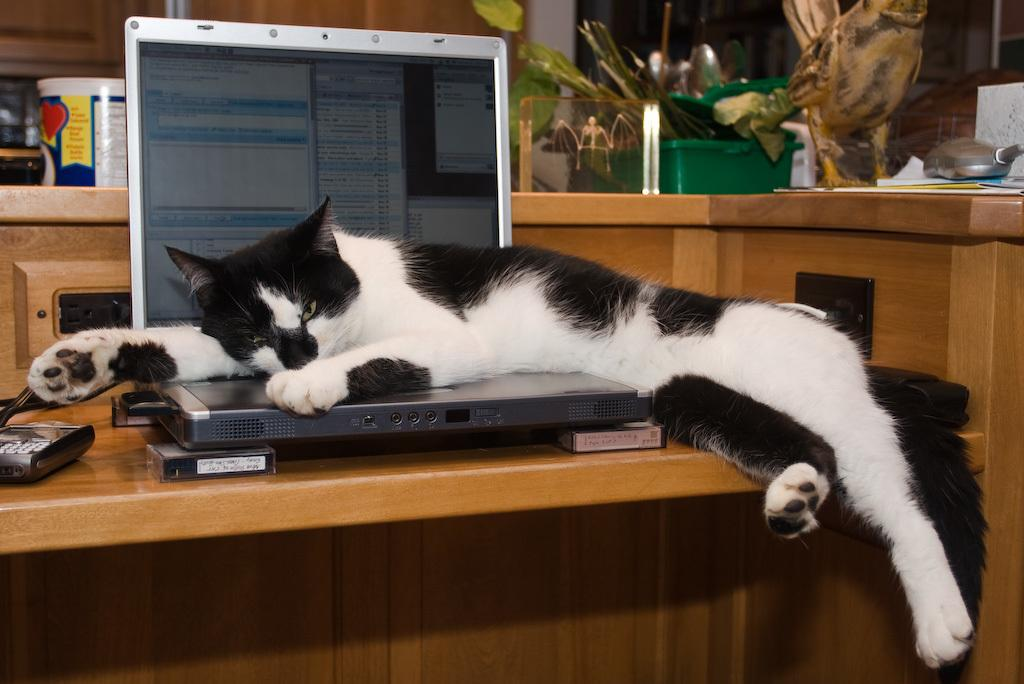What animal is present in the image? There is a cat in the image. Where is the cat located? The cat is on a laptop in the image. What can be seen on the laptop screen? There is a screen visible in the image. What object is on the table in the background of the image? There is a bottle on a table in the background of the image. What other item is present in the image? There is a box in the image. What type of stem can be seen in the image? There is no stem present in the image. 